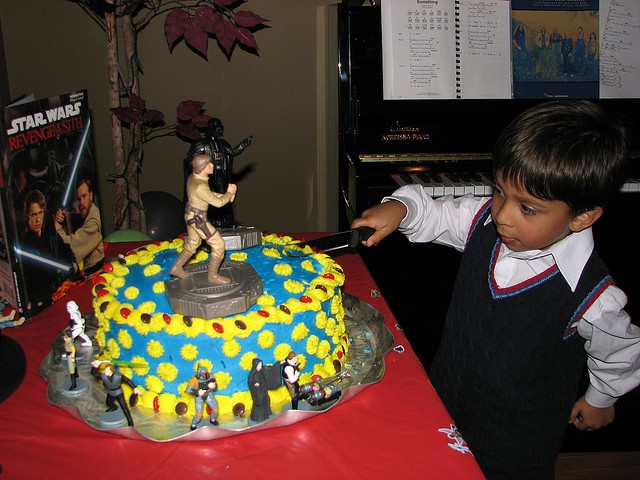Describe the objects in this image and their specific colors. I can see people in black, darkgray, lightgray, and maroon tones, cake in black, yellow, lightblue, gray, and teal tones, dining table in black, brown, and maroon tones, book in black, maroon, and darkgray tones, and book in black, darkgray, and gray tones in this image. 